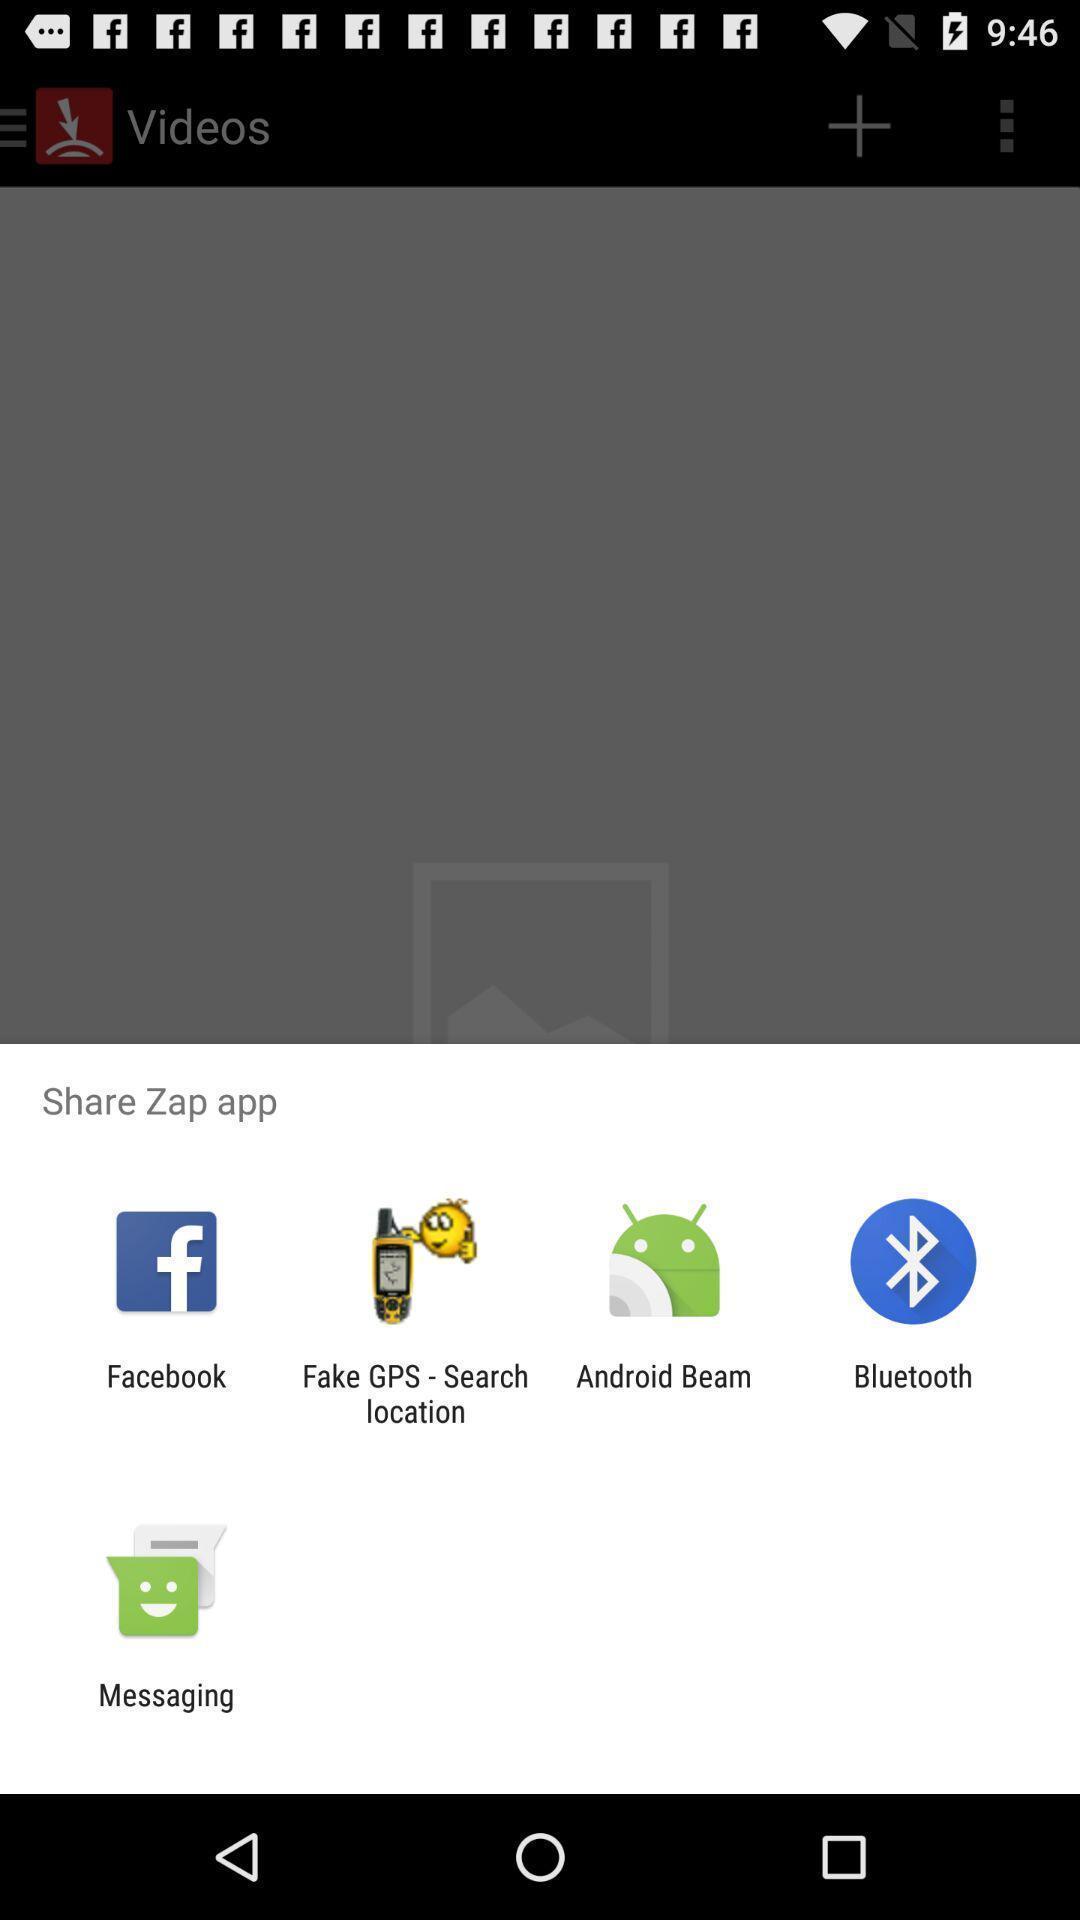Describe the key features of this screenshot. Screen showing multiple share options. 